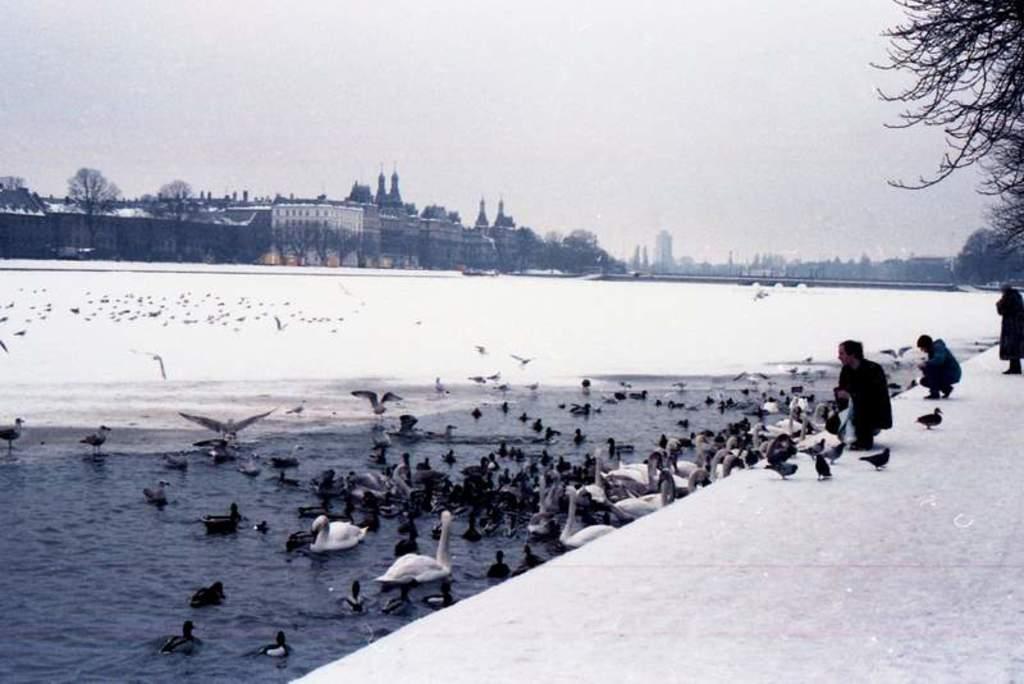How would you summarize this image in a sentence or two? In this picture I can see the birds in the middle, there is water. On the right side there are few persons, in the background there are buildings, trees and the snow. At the top I can see the sky. 